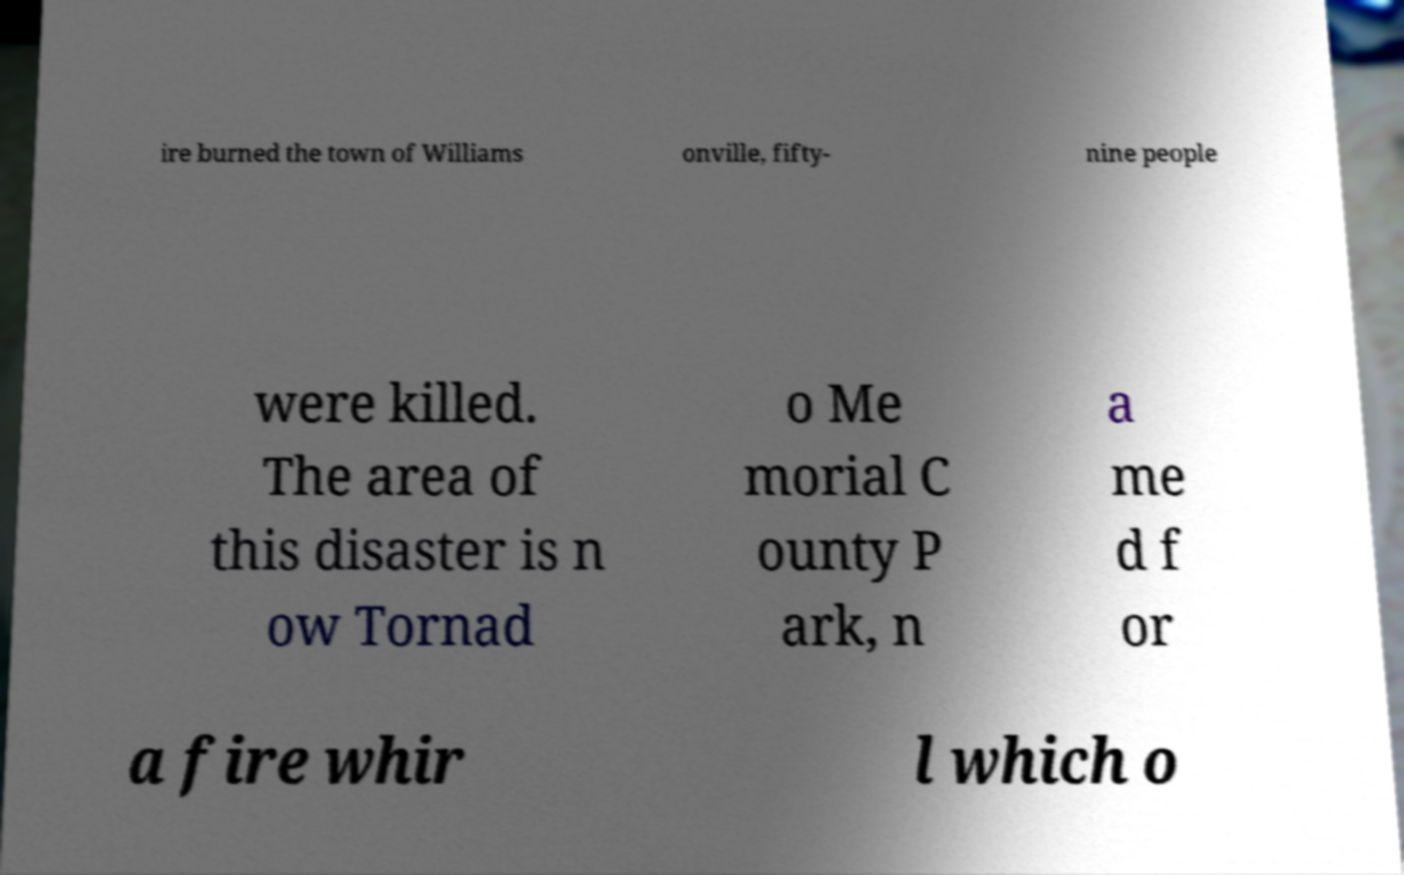What messages or text are displayed in this image? I need them in a readable, typed format. ire burned the town of Williams onville, fifty- nine people were killed. The area of this disaster is n ow Tornad o Me morial C ounty P ark, n a me d f or a fire whir l which o 